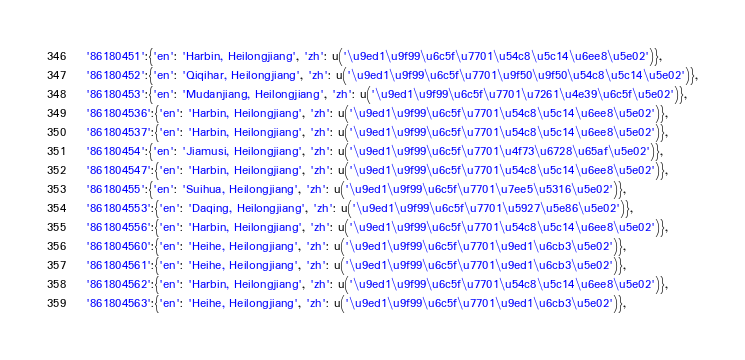<code> <loc_0><loc_0><loc_500><loc_500><_Python_> '86180451':{'en': 'Harbin, Heilongjiang', 'zh': u('\u9ed1\u9f99\u6c5f\u7701\u54c8\u5c14\u6ee8\u5e02')},
 '86180452':{'en': 'Qiqihar, Heilongjiang', 'zh': u('\u9ed1\u9f99\u6c5f\u7701\u9f50\u9f50\u54c8\u5c14\u5e02')},
 '86180453':{'en': 'Mudanjiang, Heilongjiang', 'zh': u('\u9ed1\u9f99\u6c5f\u7701\u7261\u4e39\u6c5f\u5e02')},
 '861804536':{'en': 'Harbin, Heilongjiang', 'zh': u('\u9ed1\u9f99\u6c5f\u7701\u54c8\u5c14\u6ee8\u5e02')},
 '861804537':{'en': 'Harbin, Heilongjiang', 'zh': u('\u9ed1\u9f99\u6c5f\u7701\u54c8\u5c14\u6ee8\u5e02')},
 '86180454':{'en': 'Jiamusi, Heilongjiang', 'zh': u('\u9ed1\u9f99\u6c5f\u7701\u4f73\u6728\u65af\u5e02')},
 '861804547':{'en': 'Harbin, Heilongjiang', 'zh': u('\u9ed1\u9f99\u6c5f\u7701\u54c8\u5c14\u6ee8\u5e02')},
 '86180455':{'en': 'Suihua, Heilongjiang', 'zh': u('\u9ed1\u9f99\u6c5f\u7701\u7ee5\u5316\u5e02')},
 '861804553':{'en': 'Daqing, Heilongjiang', 'zh': u('\u9ed1\u9f99\u6c5f\u7701\u5927\u5e86\u5e02')},
 '861804556':{'en': 'Harbin, Heilongjiang', 'zh': u('\u9ed1\u9f99\u6c5f\u7701\u54c8\u5c14\u6ee8\u5e02')},
 '861804560':{'en': 'Heihe, Heilongjiang', 'zh': u('\u9ed1\u9f99\u6c5f\u7701\u9ed1\u6cb3\u5e02')},
 '861804561':{'en': 'Heihe, Heilongjiang', 'zh': u('\u9ed1\u9f99\u6c5f\u7701\u9ed1\u6cb3\u5e02')},
 '861804562':{'en': 'Harbin, Heilongjiang', 'zh': u('\u9ed1\u9f99\u6c5f\u7701\u54c8\u5c14\u6ee8\u5e02')},
 '861804563':{'en': 'Heihe, Heilongjiang', 'zh': u('\u9ed1\u9f99\u6c5f\u7701\u9ed1\u6cb3\u5e02')},</code> 